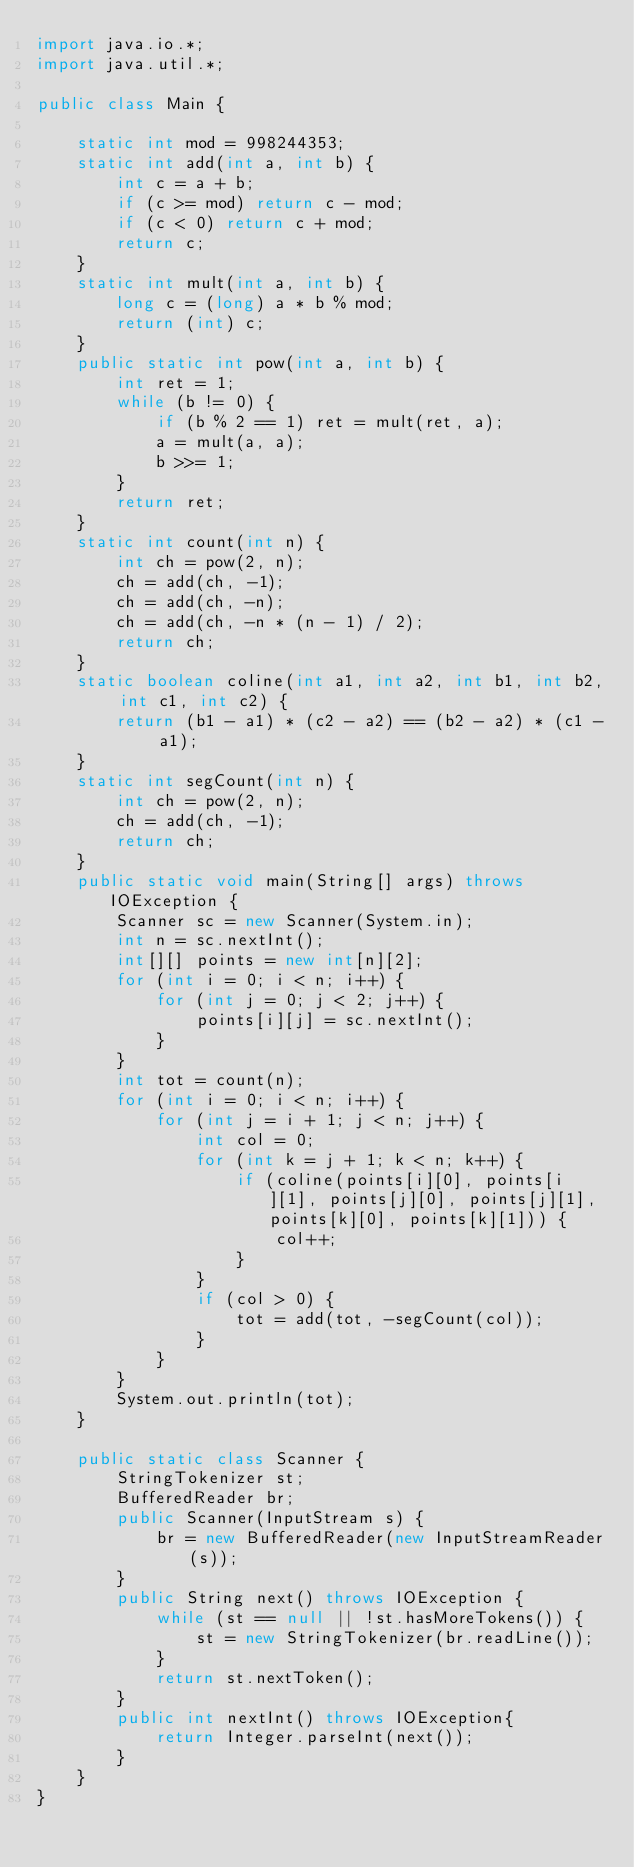<code> <loc_0><loc_0><loc_500><loc_500><_Java_>import java.io.*;
import java.util.*;

public class Main {

    static int mod = 998244353;
    static int add(int a, int b) {
        int c = a + b;
        if (c >= mod) return c - mod;
        if (c < 0) return c + mod;
        return c;
    }
    static int mult(int a, int b) {
        long c = (long) a * b % mod;
        return (int) c;
    }
    public static int pow(int a, int b) {
        int ret = 1;
        while (b != 0) {
            if (b % 2 == 1) ret = mult(ret, a);
            a = mult(a, a);
            b >>= 1;
        }
        return ret;
    }
    static int count(int n) {
        int ch = pow(2, n);
        ch = add(ch, -1);
        ch = add(ch, -n);
        ch = add(ch, -n * (n - 1) / 2);
        return ch;
    }
    static boolean coline(int a1, int a2, int b1, int b2, int c1, int c2) {
        return (b1 - a1) * (c2 - a2) == (b2 - a2) * (c1 - a1);
    }
    static int segCount(int n) {
        int ch = pow(2, n);
        ch = add(ch, -1);
        return ch;
    }
    public static void main(String[] args) throws IOException {
        Scanner sc = new Scanner(System.in);
        int n = sc.nextInt();
        int[][] points = new int[n][2];
        for (int i = 0; i < n; i++) {
            for (int j = 0; j < 2; j++) {
                points[i][j] = sc.nextInt();
            }
        }
        int tot = count(n);
        for (int i = 0; i < n; i++) {
            for (int j = i + 1; j < n; j++) {
                int col = 0;
                for (int k = j + 1; k < n; k++) {
                    if (coline(points[i][0], points[i][1], points[j][0], points[j][1], points[k][0], points[k][1])) {
                        col++;
                    }
                }
                if (col > 0) {
                    tot = add(tot, -segCount(col));
                }
            }
        }
        System.out.println(tot);
    }

    public static class Scanner {
        StringTokenizer st;
        BufferedReader br;
        public Scanner(InputStream s) {
            br = new BufferedReader(new InputStreamReader(s));
        }
        public String next() throws IOException {
            while (st == null || !st.hasMoreTokens()) {
                st = new StringTokenizer(br.readLine());
            }
            return st.nextToken();
        }
        public int nextInt() throws IOException{
            return Integer.parseInt(next());
        }
    }
}</code> 